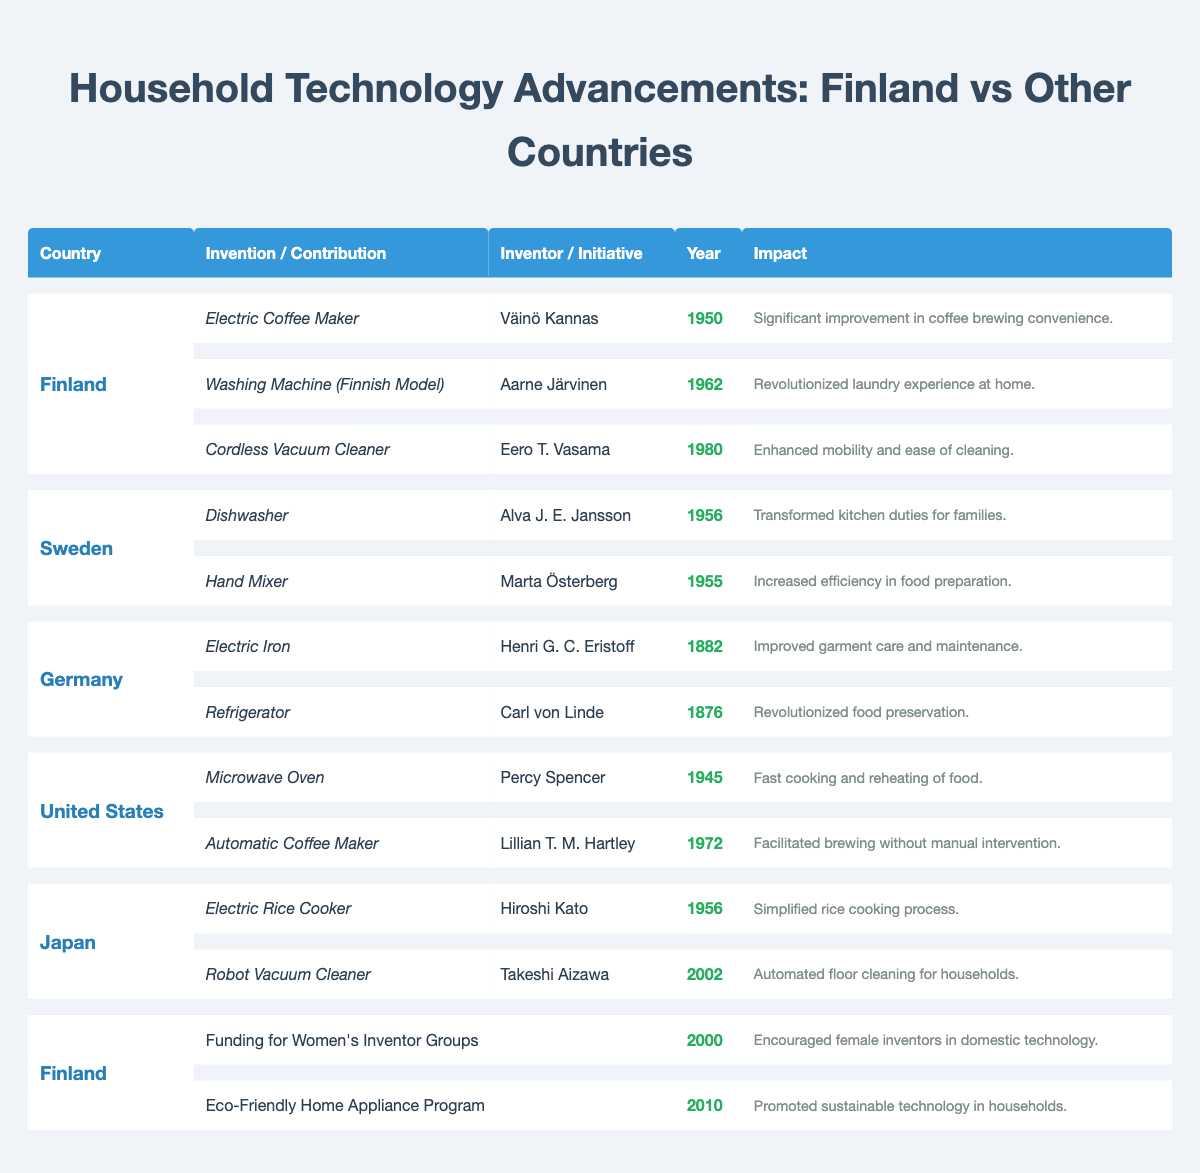What was the earliest household invention listed for Finland? The table lists the inventions from Finland in chronological order. The earliest listed invention is the Electric Coffee Maker from 1950, created by Väinö Kannas.
Answer: Electric Coffee Maker Which country invented the Robot Vacuum Cleaner and in what year? The table shows that the Robot Vacuum Cleaner was invented in Japan by Takeshi Aizawa in the year 2002.
Answer: Japan, 2002 How many inventions are recorded for Sweden? There are two inventions recorded for Sweden in the table: the Dishwasher and the Hand Mixer.
Answer: 2 What impact did the funding for Women's Inventor Groups have in Finland? The table states that this initiative, implemented in the year 2000, encouraged female inventors in domestic technology, indicating a positive impact on women's contributions in this field.
Answer: Encouraged female inventors Which country had an invention related to food preservation, and what was it? The table indicates that Germany had the Refrigerator invented by Carl von Linde in 1876, which revolutionized food preservation.
Answer: Germany, Refrigerator Which has more total inventions listed, Finland or the United States? Finland has three inventions listed (Electric Coffee Maker, Washing Machine, Cordless Vacuum Cleaner), while the United States has two (Microwave Oven, Automatic Coffee Maker). Therefore, Finland has more total inventions.
Answer: Finland Was the Electric Rice Cooker invented earlier or later than the Dishwasher? The Electric Rice Cooker was invented in 1956, which is the same year as the Dishwasher. Thus, they were invented simultaneously.
Answer: Same year Which country shows a contribution initiative for eco-friendly technology? The table shows that Finland had an Eco-Friendly Home Appliance Program initiated in 2010, promoting sustainable technology in households.
Answer: Finland What is the difference in years between the inventions of the Electric Iron and the Cordless Vacuum Cleaner? The Electric Iron was invented in 1882 and the Cordless Vacuum Cleaner in 1980. The difference is 1980 - 1882 = 98 years.
Answer: 98 years Is it true that Sweden had two inventions listed before the year 1960? The table indicates that both Swedish inventions, the Dishwasher and Hand Mixer, were invented in 1956 and 1955 respectively, which are both before 1960. Hence, the statement is true.
Answer: True 